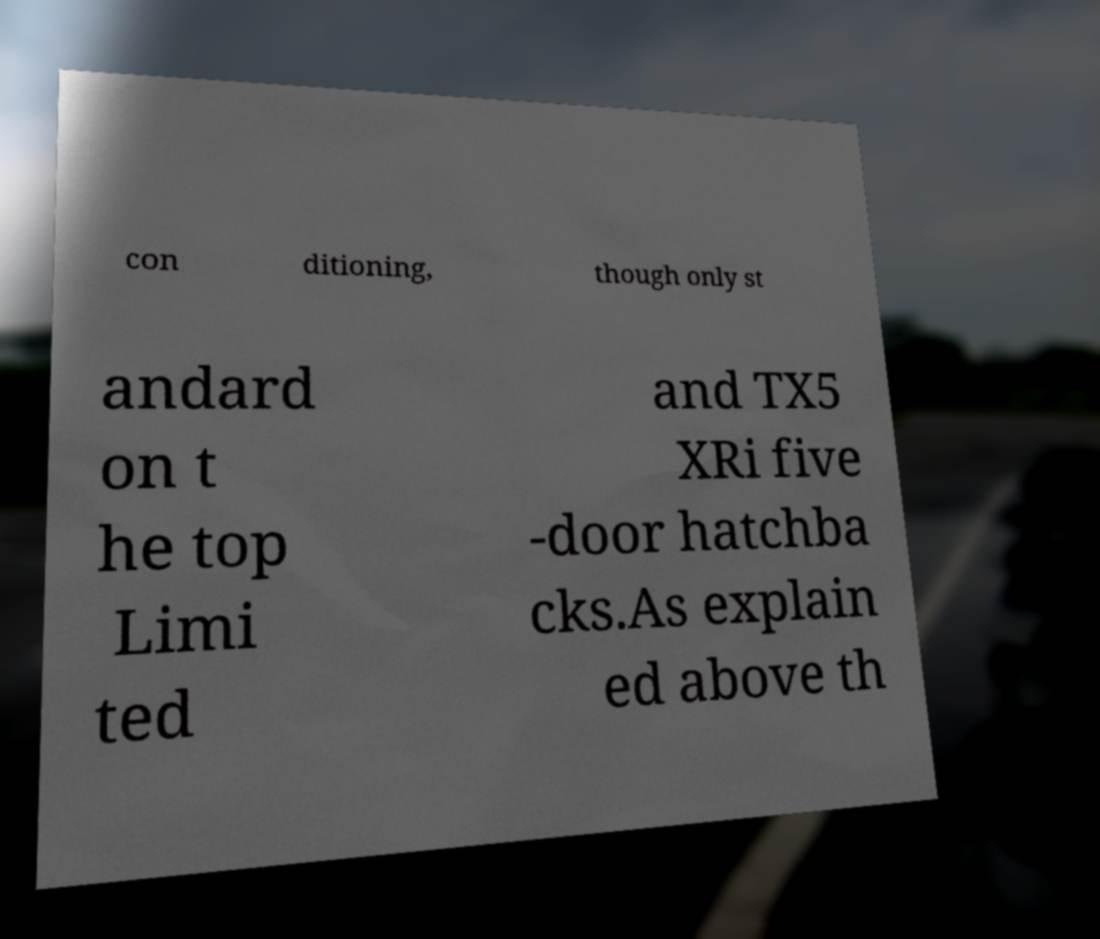What messages or text are displayed in this image? I need them in a readable, typed format. con ditioning, though only st andard on t he top Limi ted and TX5 XRi five -door hatchba cks.As explain ed above th 